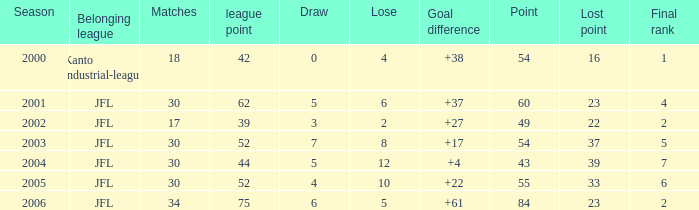What is the average loss for instances where the lost points are greater than 16, the goal difference is under 37, and the total points are below 43? None. Could you parse the entire table as a dict? {'header': ['Season', 'Belonging league', 'Matches', 'league point', 'Draw', 'Lose', 'Goal difference', 'Point', 'Lost point', 'Final rank'], 'rows': [['2000', 'Kanto industrial-league', '18', '42', '0', '4', '+38', '54', '16', '1'], ['2001', 'JFL', '30', '62', '5', '6', '+37', '60', '23', '4'], ['2002', 'JFL', '17', '39', '3', '2', '+27', '49', '22', '2'], ['2003', 'JFL', '30', '52', '7', '8', '+17', '54', '37', '5'], ['2004', 'JFL', '30', '44', '5', '12', '+4', '43', '39', '7'], ['2005', 'JFL', '30', '52', '4', '10', '+22', '55', '33', '6'], ['2006', 'JFL', '34', '75', '6', '5', '+61', '84', '23', '2']]} 